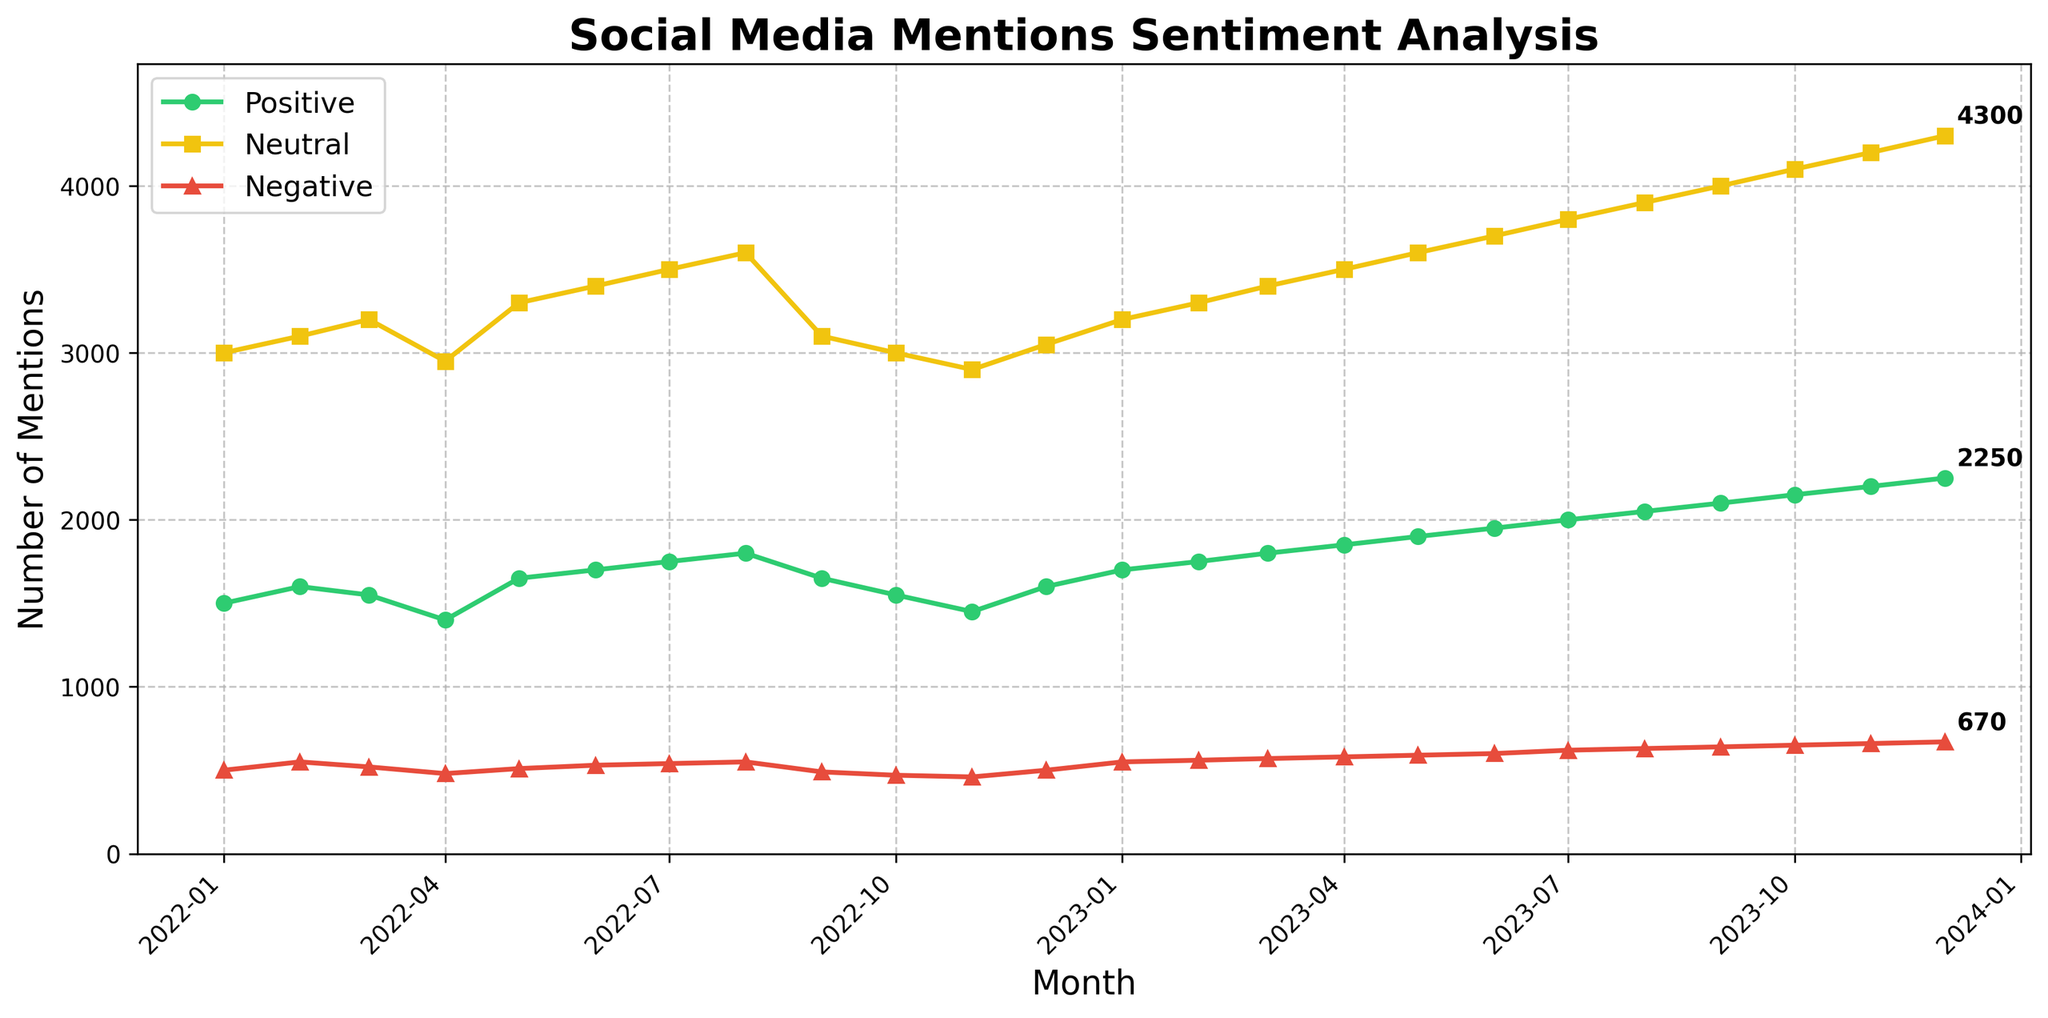What is the title of the plot? The title of the plot is displayed at the top and reads "Social Media Mentions Sentiment Analysis".
Answer: Social Media Mentions Sentiment Analysis How many categories of social media mentions are displayed in the plot? There are three categories of social media mentions displayed in the plot, identified by lines of different colors: Positive Mentions, Neutral Mentions, and Negative Mentions.
Answer: Three What is the general trend of positive mentions from January 2022 to December 2023? By observing the green line representing Positive Mentions, it is clear that there is a general upward trend from January 2022 to December 2023, with mentions starting at 1500 and rising steadily to 2250.
Answer: Upward trend Which month had the highest number of negative mentions and what is the value? By following the red line representing Negative Mentions, we see that the highest number of negative mentions occurs in December 2023 with a value of 670 mentions.
Answer: December 2023, 670 mentions Comparing July 2022 and July 2023, what is the difference in the number of positive mentions? From the green line, Positive Mentions in July 2022 are 1750 and in July 2023 are 2000. The difference is calculated as 2000 - 1750.
Answer: 250 What is the average number of neutral mentions over the entire period? Sum all the values for Neutral Mentions and divide by the number of months (24 months): (3000 + 3100 + 3200 + 2950 + 3300 + 3400 + 3500 + 3600 + 3100 + 3000 + 2900 + 3050 + 3200 + 3300 + 3400 + 3500 + 3600 + 3700 + 3800 + 3900 + 4000 + 4100 + 4200 + 4300) / 24.
Answer: 3517 Which sentiment category shows the most variation in mentions over time? By examining the amplitudes of the lines, the Neutral Mentions (yellow line) show the greatest range from roughly 2900 to 4300, indicating the most variation.
Answer: Neutral Mentions How did the number of negative mentions change between March 2023 and April 2023? From the plot, Negative Mentions in March 2023 are 570 and in April 2023 are 580. The change is found by the difference 580 - 570.
Answer: Increase by 10 In which month did all three categories have a noticeable dip, and what are the values? All three lines show a simultaneous dip in April 2022. The values are: Positive Mentions = 1400, Neutral Mentions = 2950, Negative Mentions = 480.
Answer: April 2022, 1400 (Positive), 2950 (Neutral), 480 (Negative) Which month had the lowest number of Neutral Mentions in 2022? By following the yellow line, the lowest number of Neutral Mentions in 2022 is observed in November with a value of 2900.
Answer: November 2022, 2900 